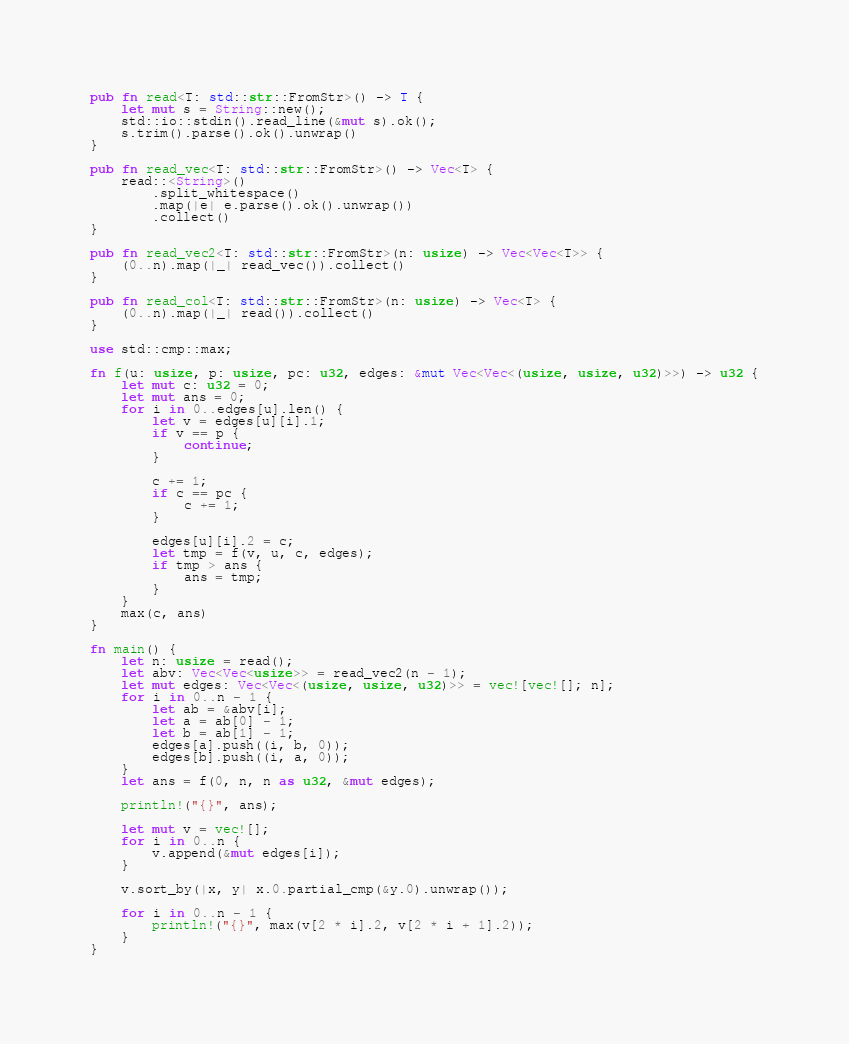<code> <loc_0><loc_0><loc_500><loc_500><_Rust_>pub fn read<T: std::str::FromStr>() -> T {
    let mut s = String::new();
    std::io::stdin().read_line(&mut s).ok();
    s.trim().parse().ok().unwrap()
}

pub fn read_vec<T: std::str::FromStr>() -> Vec<T> {
    read::<String>()
        .split_whitespace()
        .map(|e| e.parse().ok().unwrap())
        .collect()
}

pub fn read_vec2<T: std::str::FromStr>(n: usize) -> Vec<Vec<T>> {
    (0..n).map(|_| read_vec()).collect()
}

pub fn read_col<T: std::str::FromStr>(n: usize) -> Vec<T> {
    (0..n).map(|_| read()).collect()
}

use std::cmp::max;

fn f(u: usize, p: usize, pc: u32, edges: &mut Vec<Vec<(usize, usize, u32)>>) -> u32 {
    let mut c: u32 = 0;
    let mut ans = 0;
    for i in 0..edges[u].len() {
        let v = edges[u][i].1;
        if v == p {
            continue;
        }

        c += 1;
        if c == pc {
            c += 1;
        }

        edges[u][i].2 = c;
        let tmp = f(v, u, c, edges);
        if tmp > ans {
            ans = tmp;
        }
    }
    max(c, ans)
}

fn main() {
    let n: usize = read();
    let abv: Vec<Vec<usize>> = read_vec2(n - 1);
    let mut edges: Vec<Vec<(usize, usize, u32)>> = vec![vec![]; n];
    for i in 0..n - 1 {
        let ab = &abv[i];
        let a = ab[0] - 1;
        let b = ab[1] - 1;
        edges[a].push((i, b, 0));
        edges[b].push((i, a, 0));
    }
    let ans = f(0, n, n as u32, &mut edges);

    println!("{}", ans);

    let mut v = vec![];
    for i in 0..n {
        v.append(&mut edges[i]);
    }

    v.sort_by(|x, y| x.0.partial_cmp(&y.0).unwrap());

    for i in 0..n - 1 {
        println!("{}", max(v[2 * i].2, v[2 * i + 1].2));
    }
}
</code> 